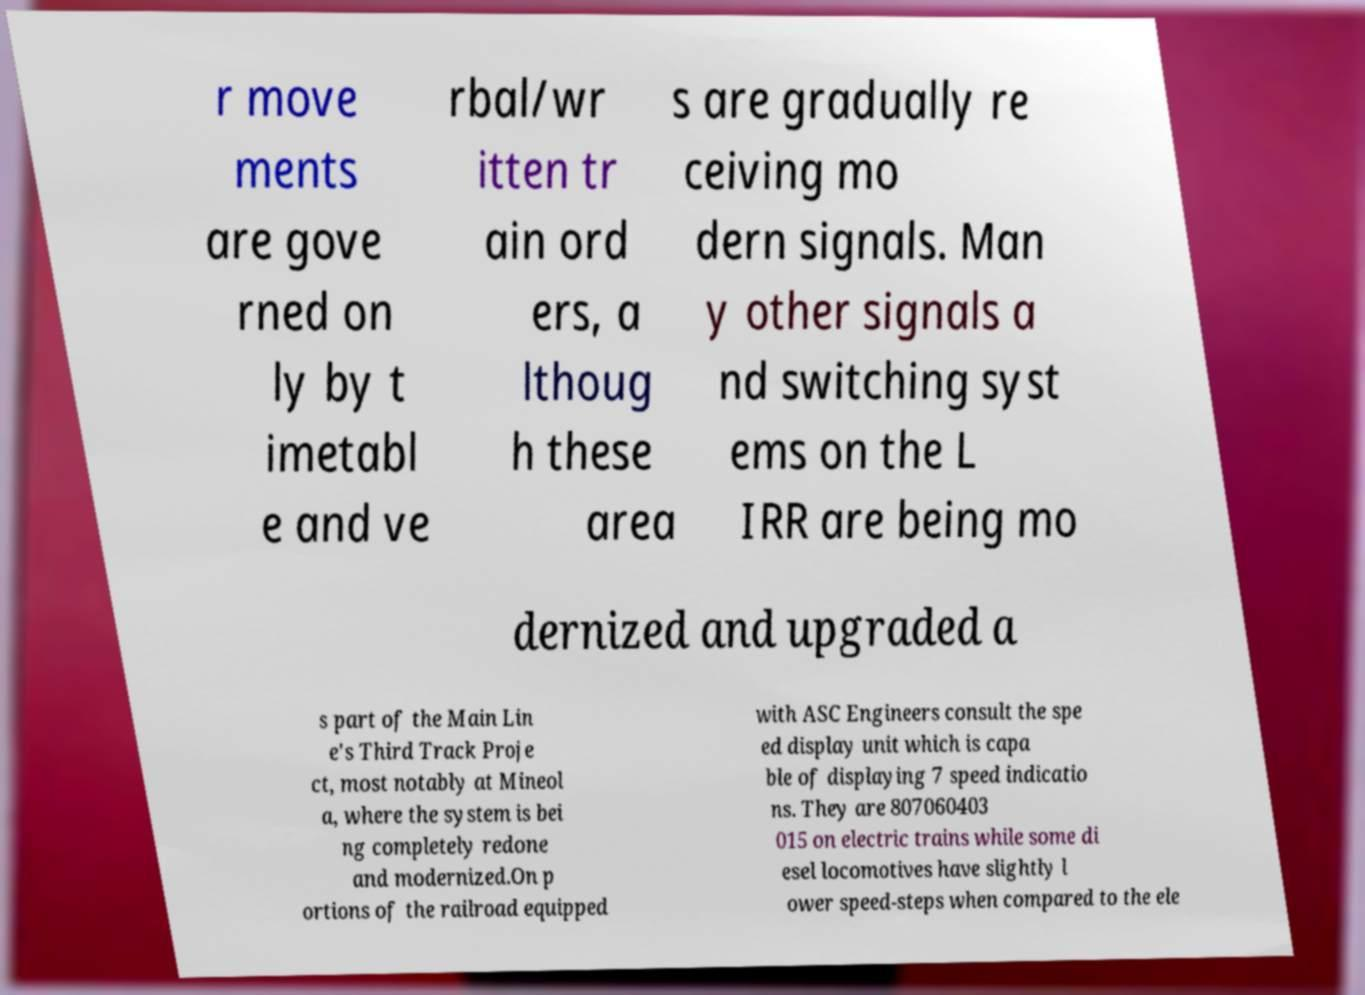Please read and relay the text visible in this image. What does it say? r move ments are gove rned on ly by t imetabl e and ve rbal/wr itten tr ain ord ers, a lthoug h these area s are gradually re ceiving mo dern signals. Man y other signals a nd switching syst ems on the L IRR are being mo dernized and upgraded a s part of the Main Lin e's Third Track Proje ct, most notably at Mineol a, where the system is bei ng completely redone and modernized.On p ortions of the railroad equipped with ASC Engineers consult the spe ed display unit which is capa ble of displaying 7 speed indicatio ns. They are 807060403 015 on electric trains while some di esel locomotives have slightly l ower speed-steps when compared to the ele 